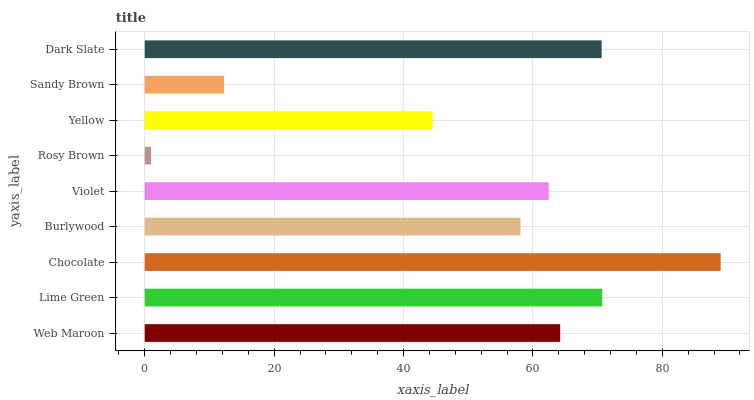Is Rosy Brown the minimum?
Answer yes or no. Yes. Is Chocolate the maximum?
Answer yes or no. Yes. Is Lime Green the minimum?
Answer yes or no. No. Is Lime Green the maximum?
Answer yes or no. No. Is Lime Green greater than Web Maroon?
Answer yes or no. Yes. Is Web Maroon less than Lime Green?
Answer yes or no. Yes. Is Web Maroon greater than Lime Green?
Answer yes or no. No. Is Lime Green less than Web Maroon?
Answer yes or no. No. Is Violet the high median?
Answer yes or no. Yes. Is Violet the low median?
Answer yes or no. Yes. Is Chocolate the high median?
Answer yes or no. No. Is Burlywood the low median?
Answer yes or no. No. 